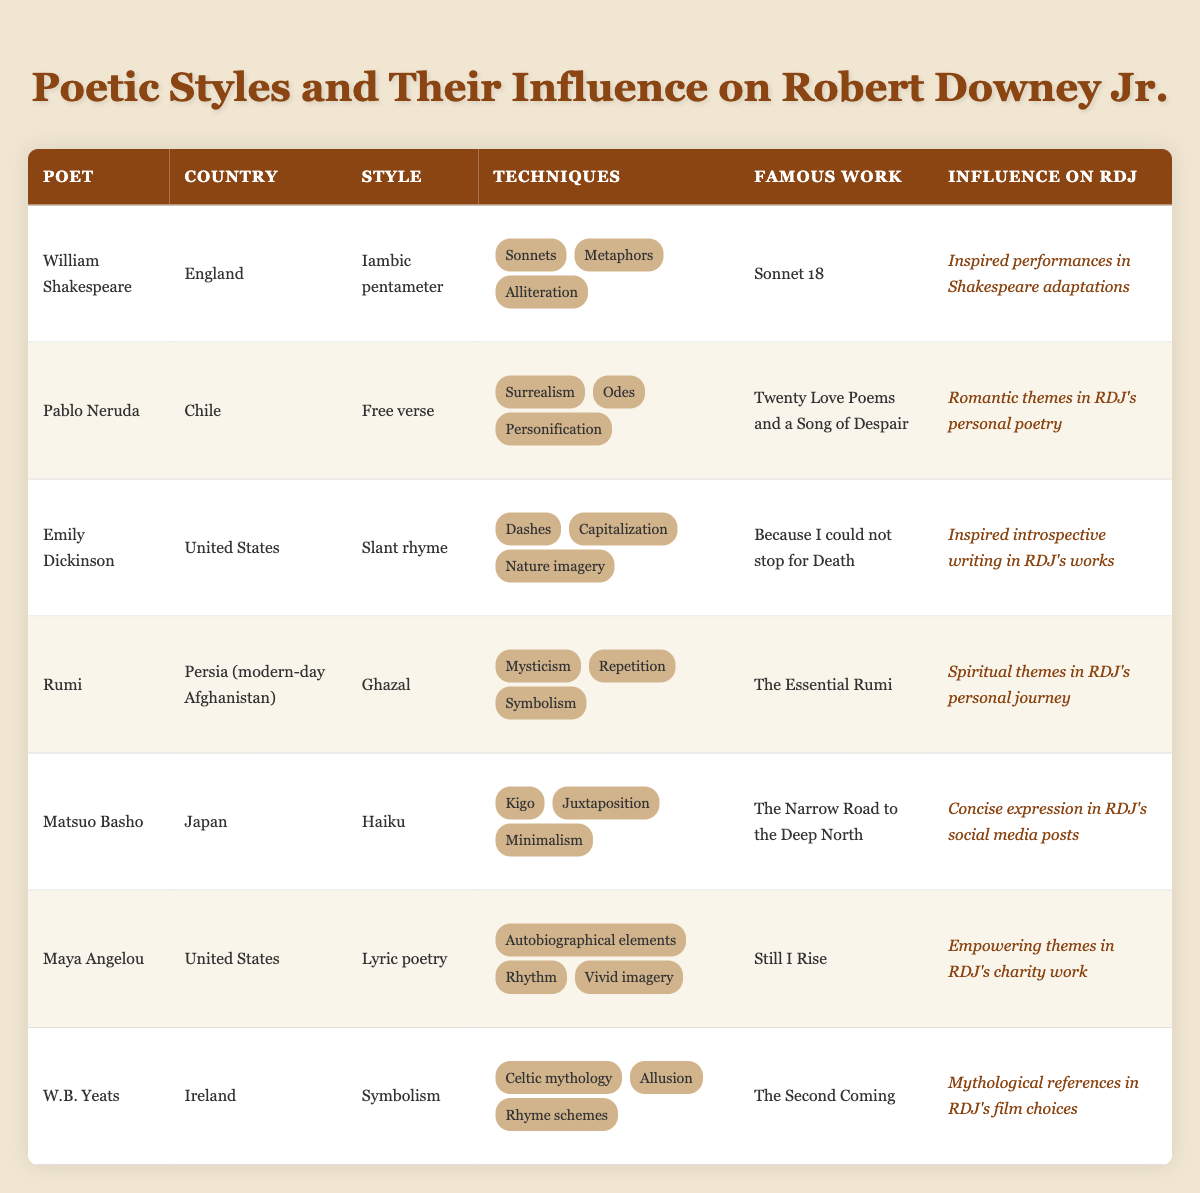What poetic style does William Shakespeare use? The table lists William Shakespeare under the "Style" column as "Iambic pentameter." This is a specific rhythmic structure used in his poetry.
Answer: Iambic pentameter Which poet's famous work includes "Still I Rise"? Referring to the "Famous Work" column, the poet associated with "Still I Rise" is Maya Angelou.
Answer: Maya Angelou Does Emily Dickinson use metaphor as one of her techniques? By examining the "Techniques" column for Emily Dickinson, it is clear she employs "Dashes," "Capitalization," and "Nature imagery," but "Metaphors" is not listed among her techniques.
Answer: No Which poet is known for using "Haiku" as their poetic style? The table indicates that Matsuo Basho is associated with "Haiku" under the "Style" column.
Answer: Matsuo Basho How many poets in the table are from the United States? By counting the entries in the table, Maya Angelou and Emily Dickinson are noted as poets from the United States. Thus, there are two poets listed.
Answer: 2 Which poet's techniques include "Celtic mythology"? Looking at the "Techniques" column, W.B. Yeats is the poet associated with "Celtic mythology."
Answer: W.B. Yeats What is the collective number of poets using “Free verse” and “Lyric poetry”? The poets who use "Free verse" is Pablo Neruda and those using "Lyric poetry" is Maya Angelou. Adding 1 (for each poet) gives a total of 2 poets.
Answer: 2 Is Rumi's famous work titled "The Essential Rumi"? Yes, the table clearly states under the "Famous Work" column for Rumi that his famous work is titled "The Essential Rumi."
Answer: Yes Which poet's influence on Robert Downey Jr. relates to "Spiritual themes"? The influence of Rumi on RDJ is described as relating to "Spiritual themes" in the table.
Answer: Rumi 